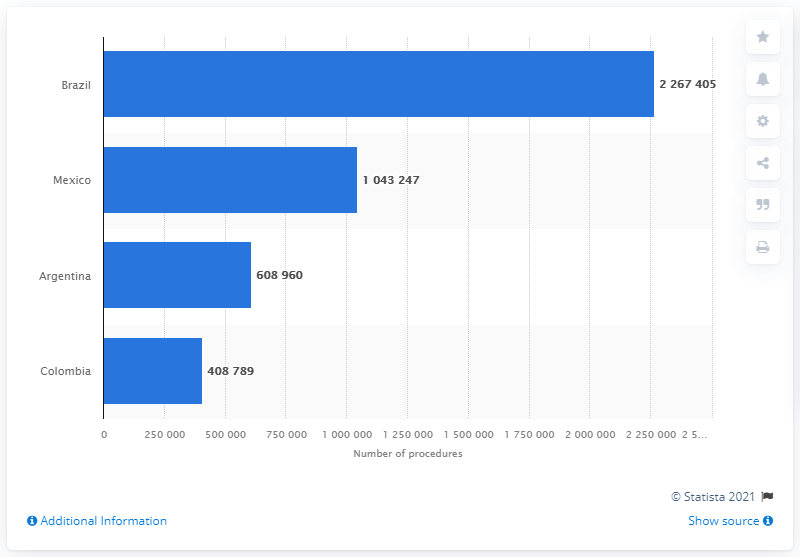Draw attention to some important aspects in this diagram. In 2018, a total of 226,7405 cosmetic surgery procedures were performed in Brazil. Brazil performed the highest number of cosmetic surgery procedures in 2018, among all countries. Mexico performed the most cosmetic surgery procedures in 2018. 